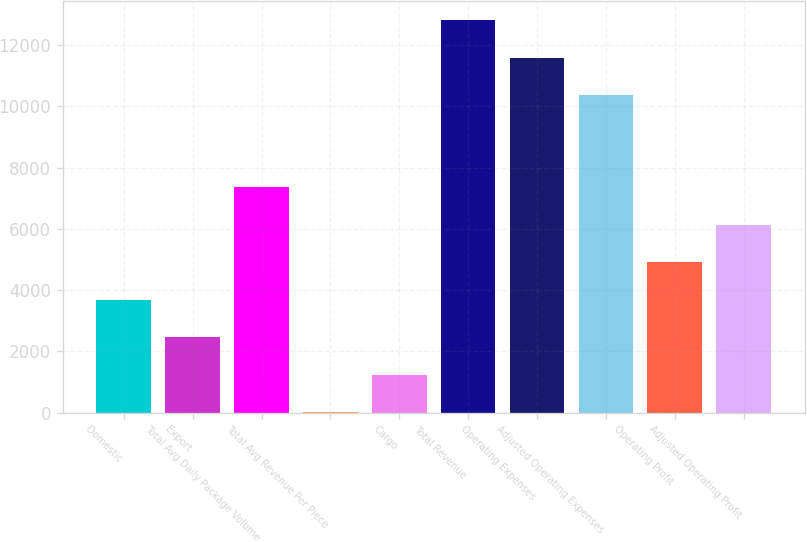Convert chart. <chart><loc_0><loc_0><loc_500><loc_500><bar_chart><fcel>Domestic<fcel>Export<fcel>Total Avg Daily Package Volume<fcel>Total Avg Revenue Per Piece<fcel>Cargo<fcel>Total Revenue<fcel>Operating Expenses<fcel>Adjusted Operating Expenses<fcel>Operating Profit<fcel>Adjusted Operating Profit<nl><fcel>3688.19<fcel>2465.22<fcel>7357.1<fcel>19.28<fcel>1242.25<fcel>12814.9<fcel>11592<fcel>10369<fcel>4911.16<fcel>6134.13<nl></chart> 